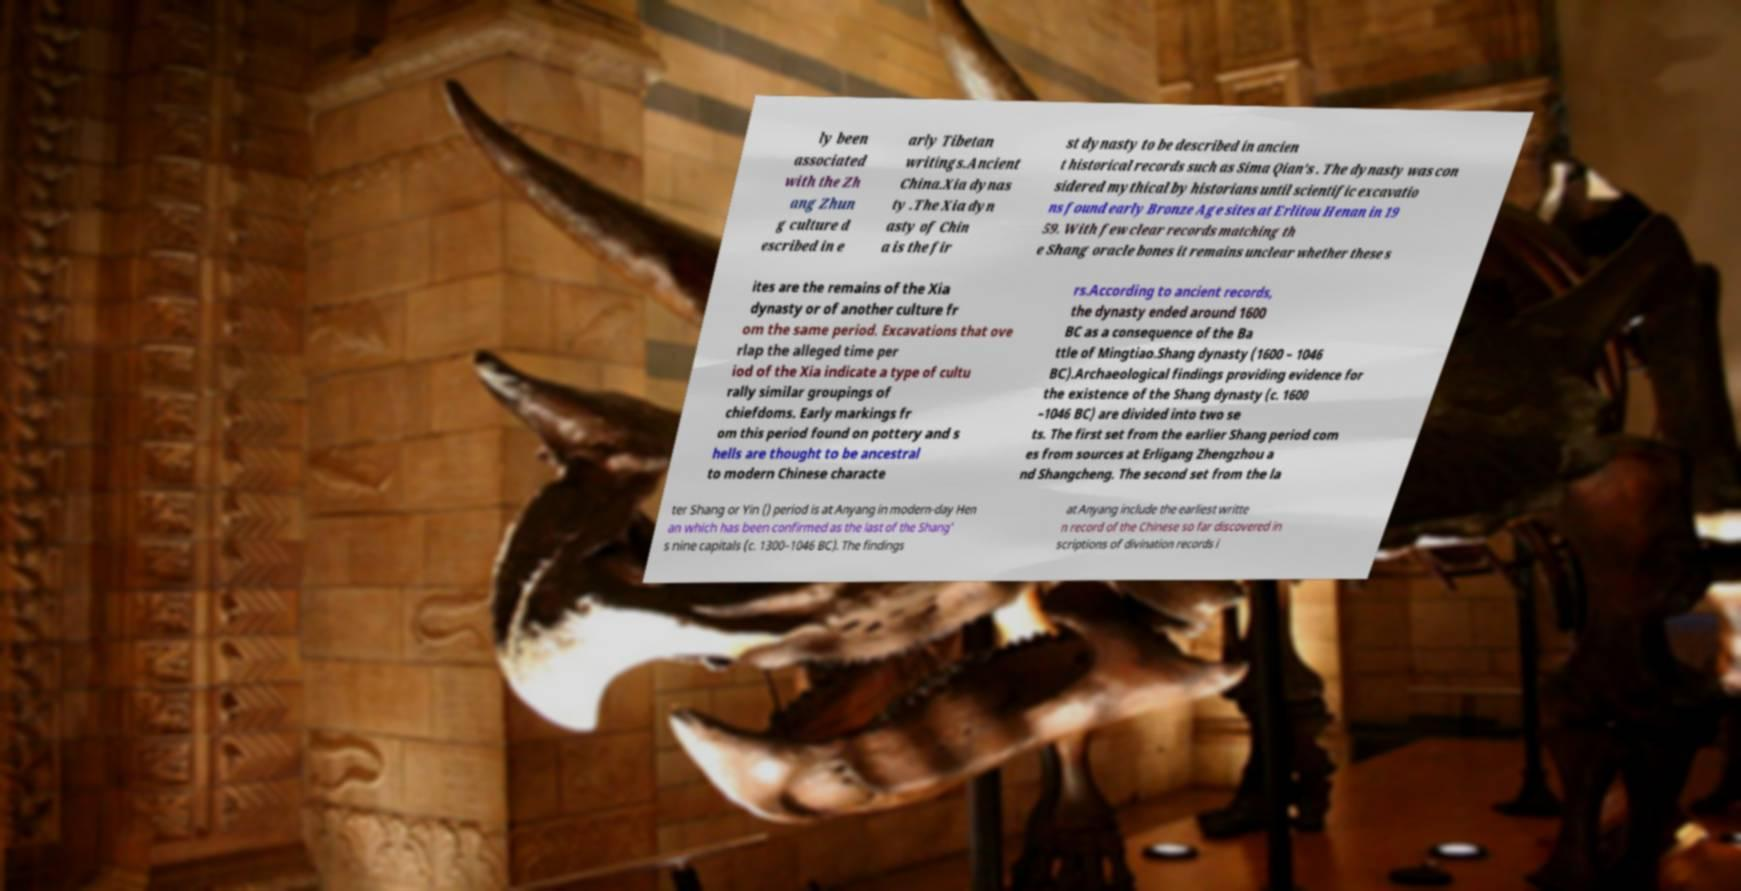Please read and relay the text visible in this image. What does it say? ly been associated with the Zh ang Zhun g culture d escribed in e arly Tibetan writings.Ancient China.Xia dynas ty .The Xia dyn asty of Chin a is the fir st dynasty to be described in ancien t historical records such as Sima Qian's . The dynasty was con sidered mythical by historians until scientific excavatio ns found early Bronze Age sites at Erlitou Henan in 19 59. With few clear records matching th e Shang oracle bones it remains unclear whether these s ites are the remains of the Xia dynasty or of another culture fr om the same period. Excavations that ove rlap the alleged time per iod of the Xia indicate a type of cultu rally similar groupings of chiefdoms. Early markings fr om this period found on pottery and s hells are thought to be ancestral to modern Chinese characte rs.According to ancient records, the dynasty ended around 1600 BC as a consequence of the Ba ttle of Mingtiao.Shang dynasty (1600 – 1046 BC).Archaeological findings providing evidence for the existence of the Shang dynasty (c. 1600 –1046 BC) are divided into two se ts. The first set from the earlier Shang period com es from sources at Erligang Zhengzhou a nd Shangcheng. The second set from the la ter Shang or Yin () period is at Anyang in modern-day Hen an which has been confirmed as the last of the Shang' s nine capitals (c. 1300–1046 BC). The findings at Anyang include the earliest writte n record of the Chinese so far discovered in scriptions of divination records i 